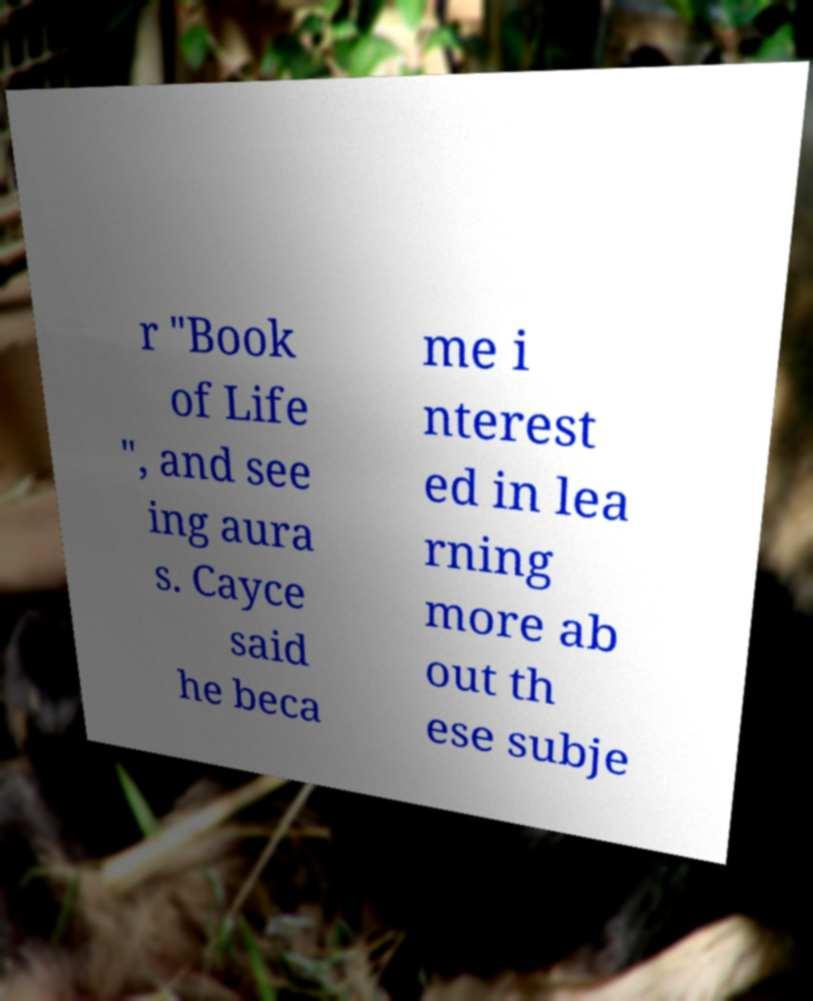What messages or text are displayed in this image? I need them in a readable, typed format. r "Book of Life ", and see ing aura s. Cayce said he beca me i nterest ed in lea rning more ab out th ese subje 